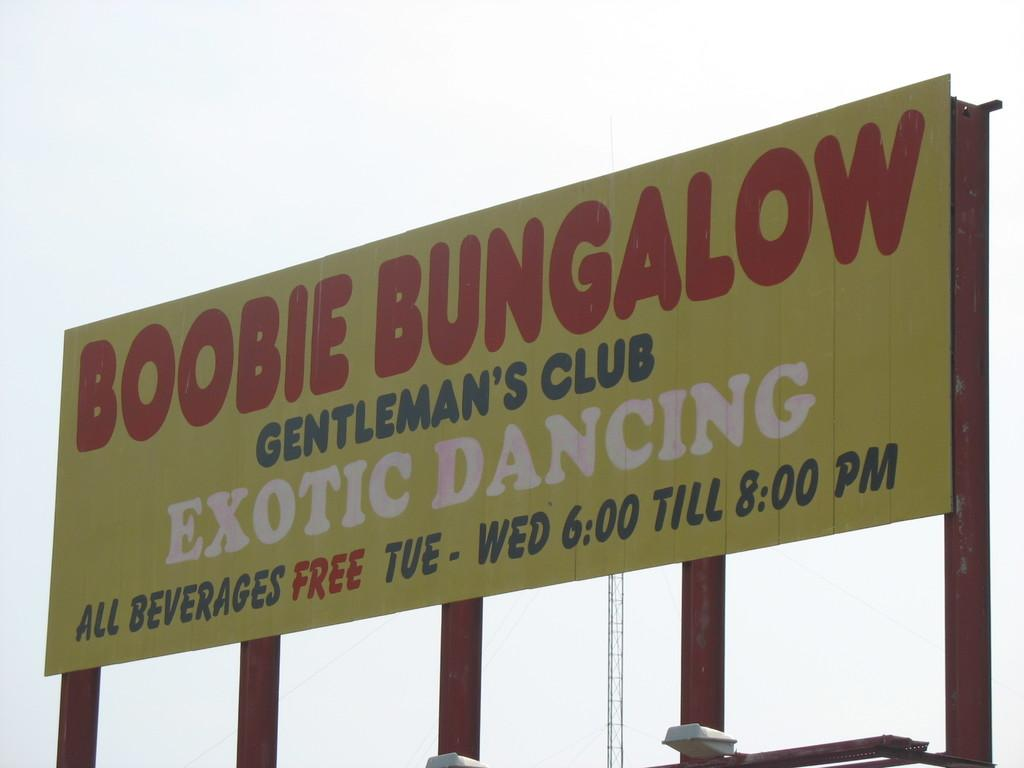<image>
Summarize the visual content of the image. Billboard for the Boobie Bungalow gentleman's club displayed high in the sky. 